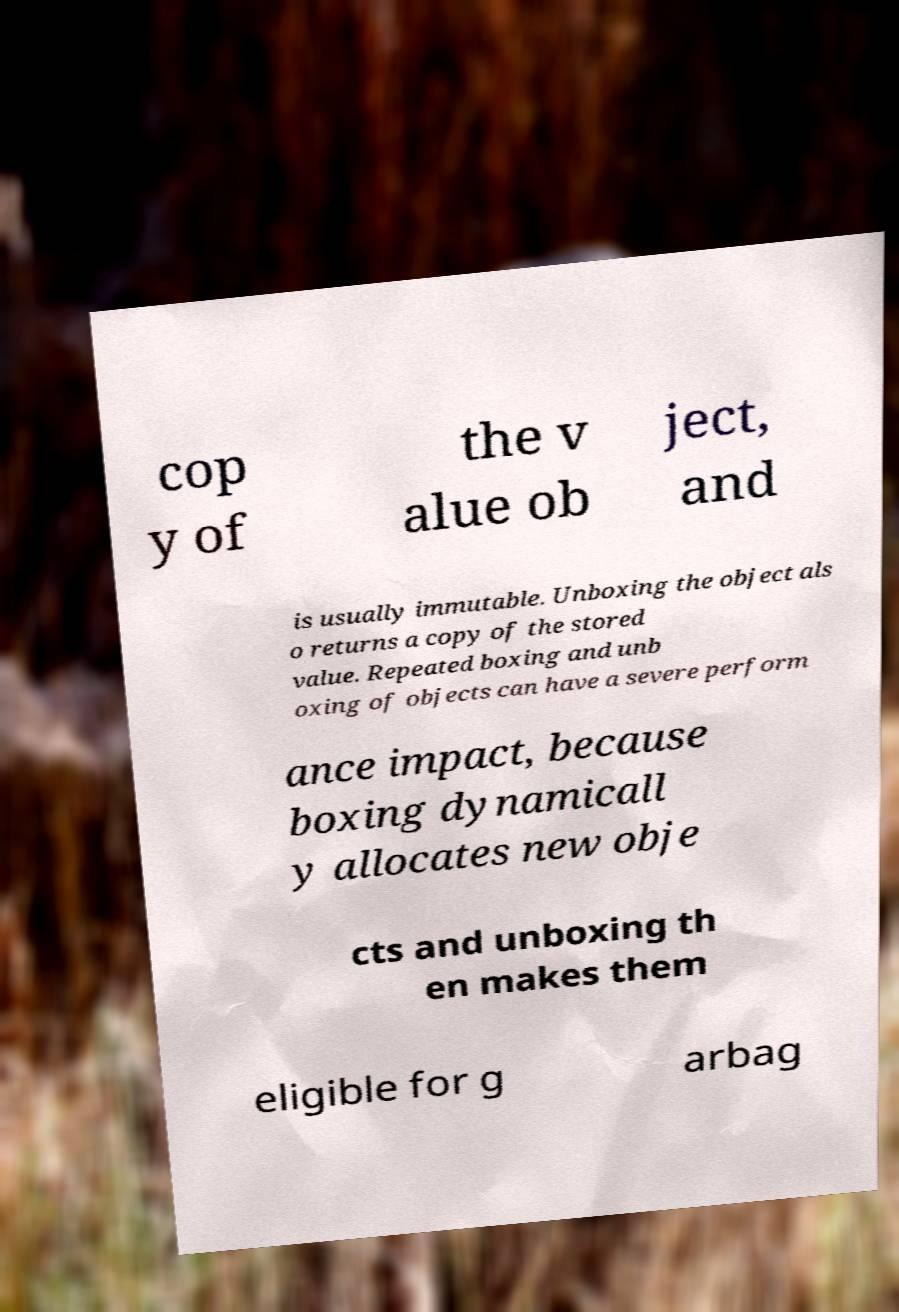Can you accurately transcribe the text from the provided image for me? cop y of the v alue ob ject, and is usually immutable. Unboxing the object als o returns a copy of the stored value. Repeated boxing and unb oxing of objects can have a severe perform ance impact, because boxing dynamicall y allocates new obje cts and unboxing th en makes them eligible for g arbag 